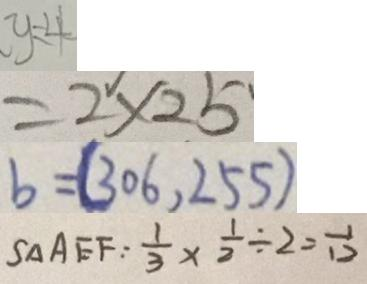Convert formula to latex. <formula><loc_0><loc_0><loc_500><loc_500>y = 4 
 = 2 \times 2 5 
 b = ( 3 0 6 , 2 5 5 ) 
 S _ { \Delta } A E F : \frac { 1 } { 3 } \times \frac { 1 } { 2 } \div 2 = \frac { 1 } { 1 2 }</formula> 